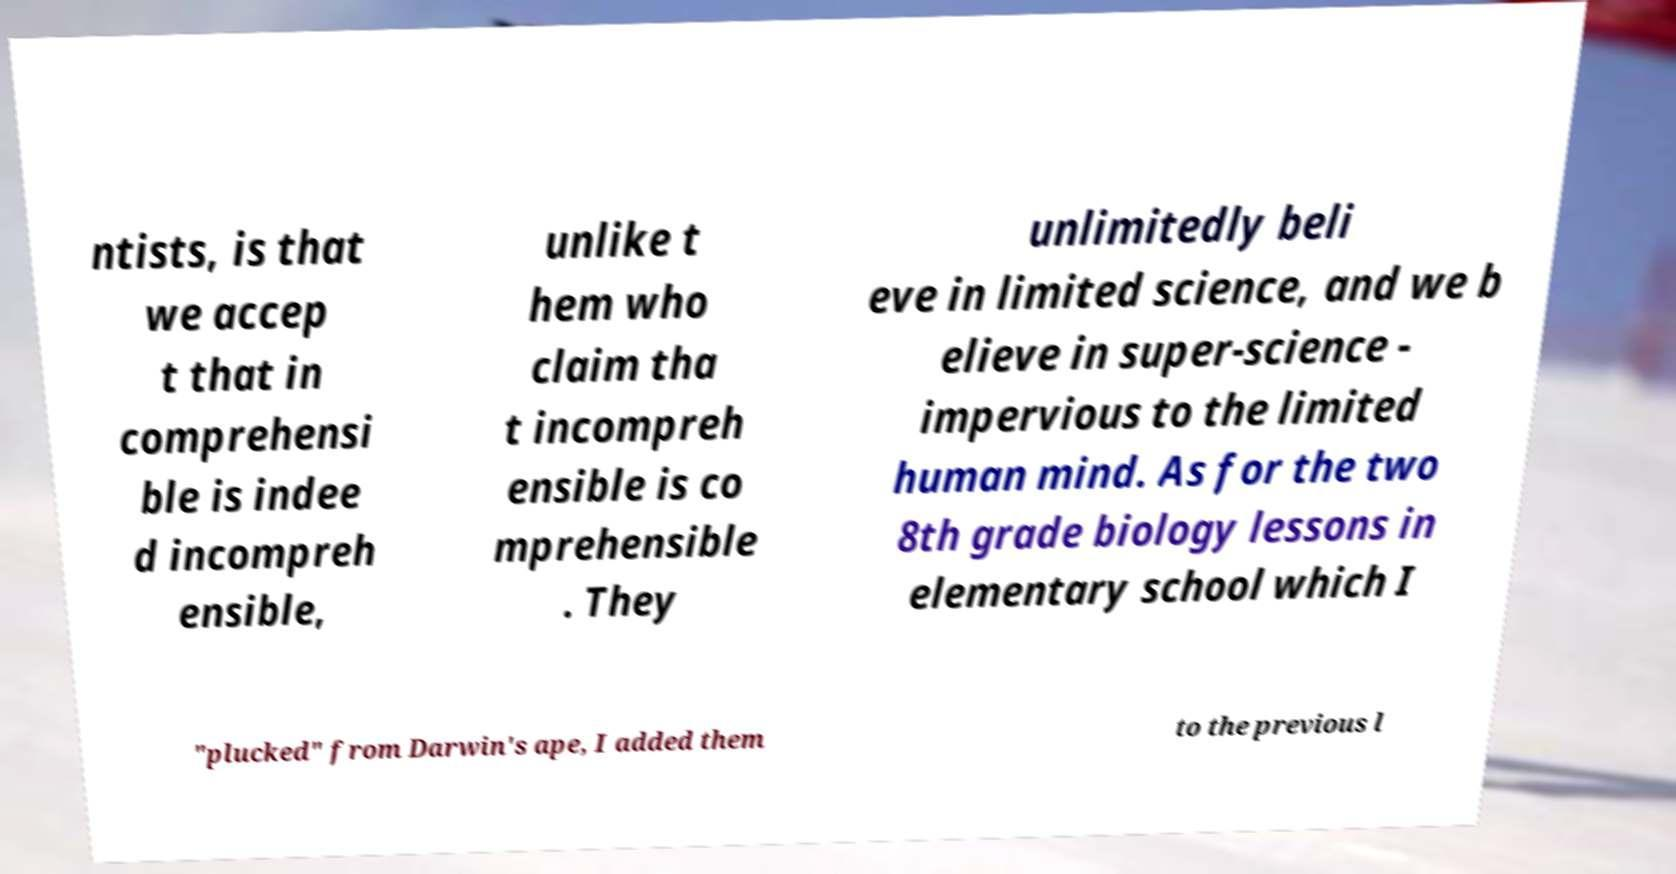There's text embedded in this image that I need extracted. Can you transcribe it verbatim? ntists, is that we accep t that in comprehensi ble is indee d incompreh ensible, unlike t hem who claim tha t incompreh ensible is co mprehensible . They unlimitedly beli eve in limited science, and we b elieve in super-science - impervious to the limited human mind. As for the two 8th grade biology lessons in elementary school which I "plucked" from Darwin's ape, I added them to the previous l 